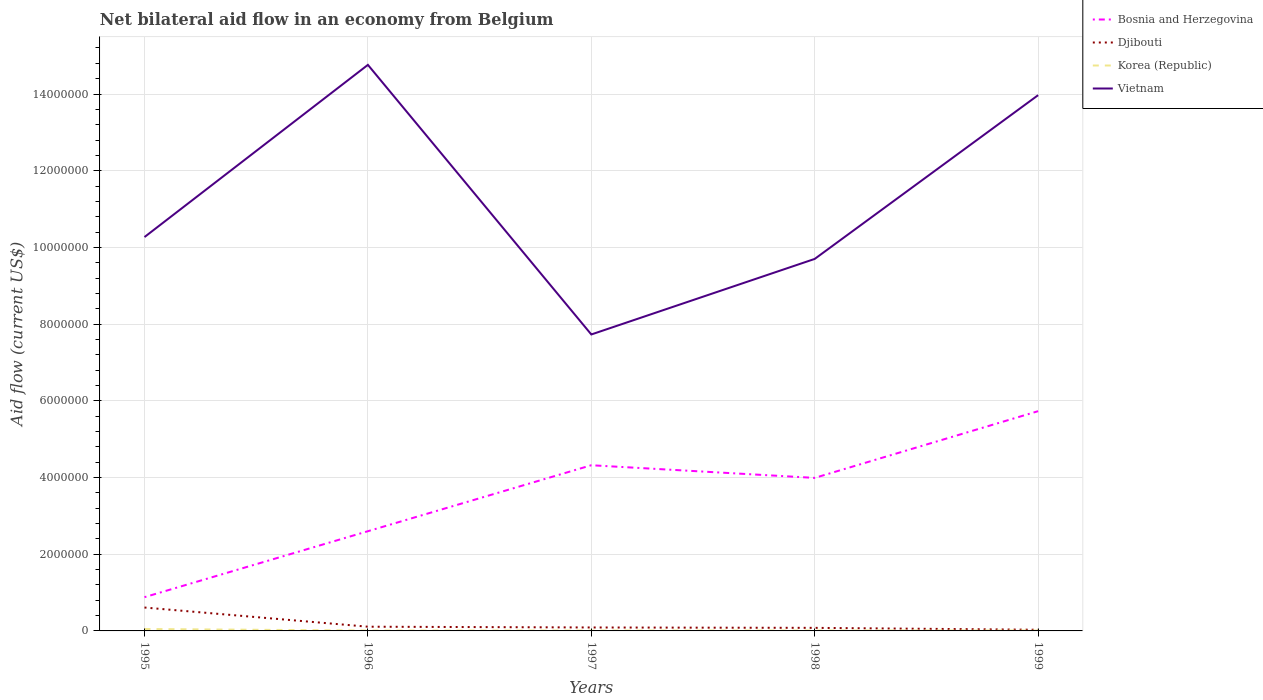How many different coloured lines are there?
Your response must be concise. 4. Across all years, what is the maximum net bilateral aid flow in Vietnam?
Your answer should be very brief. 7.73e+06. What is the total net bilateral aid flow in Korea (Republic) in the graph?
Provide a succinct answer. 0. What is the difference between the highest and the lowest net bilateral aid flow in Korea (Republic)?
Give a very brief answer. 1. What is the difference between two consecutive major ticks on the Y-axis?
Keep it short and to the point. 2.00e+06. Are the values on the major ticks of Y-axis written in scientific E-notation?
Make the answer very short. No. Where does the legend appear in the graph?
Your answer should be very brief. Top right. How many legend labels are there?
Provide a short and direct response. 4. How are the legend labels stacked?
Keep it short and to the point. Vertical. What is the title of the graph?
Offer a very short reply. Net bilateral aid flow in an economy from Belgium. What is the label or title of the X-axis?
Your answer should be very brief. Years. What is the label or title of the Y-axis?
Your answer should be very brief. Aid flow (current US$). What is the Aid flow (current US$) of Bosnia and Herzegovina in 1995?
Give a very brief answer. 8.80e+05. What is the Aid flow (current US$) of Djibouti in 1995?
Provide a succinct answer. 6.10e+05. What is the Aid flow (current US$) in Vietnam in 1995?
Give a very brief answer. 1.03e+07. What is the Aid flow (current US$) of Bosnia and Herzegovina in 1996?
Make the answer very short. 2.60e+06. What is the Aid flow (current US$) in Vietnam in 1996?
Your answer should be very brief. 1.48e+07. What is the Aid flow (current US$) in Bosnia and Herzegovina in 1997?
Keep it short and to the point. 4.32e+06. What is the Aid flow (current US$) of Djibouti in 1997?
Your response must be concise. 9.00e+04. What is the Aid flow (current US$) of Vietnam in 1997?
Your answer should be compact. 7.73e+06. What is the Aid flow (current US$) of Bosnia and Herzegovina in 1998?
Your response must be concise. 3.99e+06. What is the Aid flow (current US$) of Djibouti in 1998?
Provide a short and direct response. 8.00e+04. What is the Aid flow (current US$) of Vietnam in 1998?
Your answer should be compact. 9.70e+06. What is the Aid flow (current US$) in Bosnia and Herzegovina in 1999?
Provide a short and direct response. 5.73e+06. What is the Aid flow (current US$) in Vietnam in 1999?
Ensure brevity in your answer.  1.40e+07. Across all years, what is the maximum Aid flow (current US$) of Bosnia and Herzegovina?
Keep it short and to the point. 5.73e+06. Across all years, what is the maximum Aid flow (current US$) in Djibouti?
Give a very brief answer. 6.10e+05. Across all years, what is the maximum Aid flow (current US$) of Korea (Republic)?
Offer a terse response. 5.00e+04. Across all years, what is the maximum Aid flow (current US$) in Vietnam?
Provide a succinct answer. 1.48e+07. Across all years, what is the minimum Aid flow (current US$) of Bosnia and Herzegovina?
Make the answer very short. 8.80e+05. Across all years, what is the minimum Aid flow (current US$) in Djibouti?
Provide a succinct answer. 3.00e+04. Across all years, what is the minimum Aid flow (current US$) of Vietnam?
Ensure brevity in your answer.  7.73e+06. What is the total Aid flow (current US$) in Bosnia and Herzegovina in the graph?
Offer a very short reply. 1.75e+07. What is the total Aid flow (current US$) of Djibouti in the graph?
Provide a short and direct response. 9.20e+05. What is the total Aid flow (current US$) in Vietnam in the graph?
Ensure brevity in your answer.  5.64e+07. What is the difference between the Aid flow (current US$) in Bosnia and Herzegovina in 1995 and that in 1996?
Make the answer very short. -1.72e+06. What is the difference between the Aid flow (current US$) of Djibouti in 1995 and that in 1996?
Your answer should be very brief. 5.00e+05. What is the difference between the Aid flow (current US$) of Korea (Republic) in 1995 and that in 1996?
Your answer should be compact. 4.00e+04. What is the difference between the Aid flow (current US$) in Vietnam in 1995 and that in 1996?
Ensure brevity in your answer.  -4.49e+06. What is the difference between the Aid flow (current US$) of Bosnia and Herzegovina in 1995 and that in 1997?
Offer a very short reply. -3.44e+06. What is the difference between the Aid flow (current US$) of Djibouti in 1995 and that in 1997?
Make the answer very short. 5.20e+05. What is the difference between the Aid flow (current US$) in Vietnam in 1995 and that in 1997?
Your answer should be compact. 2.54e+06. What is the difference between the Aid flow (current US$) of Bosnia and Herzegovina in 1995 and that in 1998?
Keep it short and to the point. -3.11e+06. What is the difference between the Aid flow (current US$) of Djibouti in 1995 and that in 1998?
Your answer should be compact. 5.30e+05. What is the difference between the Aid flow (current US$) of Vietnam in 1995 and that in 1998?
Make the answer very short. 5.70e+05. What is the difference between the Aid flow (current US$) in Bosnia and Herzegovina in 1995 and that in 1999?
Your answer should be very brief. -4.85e+06. What is the difference between the Aid flow (current US$) of Djibouti in 1995 and that in 1999?
Your response must be concise. 5.80e+05. What is the difference between the Aid flow (current US$) of Korea (Republic) in 1995 and that in 1999?
Your answer should be very brief. 4.00e+04. What is the difference between the Aid flow (current US$) of Vietnam in 1995 and that in 1999?
Ensure brevity in your answer.  -3.70e+06. What is the difference between the Aid flow (current US$) of Bosnia and Herzegovina in 1996 and that in 1997?
Make the answer very short. -1.72e+06. What is the difference between the Aid flow (current US$) of Djibouti in 1996 and that in 1997?
Make the answer very short. 2.00e+04. What is the difference between the Aid flow (current US$) in Korea (Republic) in 1996 and that in 1997?
Give a very brief answer. 0. What is the difference between the Aid flow (current US$) in Vietnam in 1996 and that in 1997?
Your response must be concise. 7.03e+06. What is the difference between the Aid flow (current US$) of Bosnia and Herzegovina in 1996 and that in 1998?
Provide a succinct answer. -1.39e+06. What is the difference between the Aid flow (current US$) in Djibouti in 1996 and that in 1998?
Make the answer very short. 3.00e+04. What is the difference between the Aid flow (current US$) in Vietnam in 1996 and that in 1998?
Give a very brief answer. 5.06e+06. What is the difference between the Aid flow (current US$) of Bosnia and Herzegovina in 1996 and that in 1999?
Make the answer very short. -3.13e+06. What is the difference between the Aid flow (current US$) in Djibouti in 1996 and that in 1999?
Make the answer very short. 8.00e+04. What is the difference between the Aid flow (current US$) of Vietnam in 1996 and that in 1999?
Your answer should be very brief. 7.90e+05. What is the difference between the Aid flow (current US$) in Korea (Republic) in 1997 and that in 1998?
Make the answer very short. 0. What is the difference between the Aid flow (current US$) of Vietnam in 1997 and that in 1998?
Make the answer very short. -1.97e+06. What is the difference between the Aid flow (current US$) of Bosnia and Herzegovina in 1997 and that in 1999?
Your answer should be compact. -1.41e+06. What is the difference between the Aid flow (current US$) in Korea (Republic) in 1997 and that in 1999?
Keep it short and to the point. 0. What is the difference between the Aid flow (current US$) of Vietnam in 1997 and that in 1999?
Keep it short and to the point. -6.24e+06. What is the difference between the Aid flow (current US$) of Bosnia and Herzegovina in 1998 and that in 1999?
Keep it short and to the point. -1.74e+06. What is the difference between the Aid flow (current US$) in Vietnam in 1998 and that in 1999?
Give a very brief answer. -4.27e+06. What is the difference between the Aid flow (current US$) of Bosnia and Herzegovina in 1995 and the Aid flow (current US$) of Djibouti in 1996?
Provide a succinct answer. 7.70e+05. What is the difference between the Aid flow (current US$) in Bosnia and Herzegovina in 1995 and the Aid flow (current US$) in Korea (Republic) in 1996?
Offer a very short reply. 8.70e+05. What is the difference between the Aid flow (current US$) of Bosnia and Herzegovina in 1995 and the Aid flow (current US$) of Vietnam in 1996?
Offer a very short reply. -1.39e+07. What is the difference between the Aid flow (current US$) in Djibouti in 1995 and the Aid flow (current US$) in Korea (Republic) in 1996?
Make the answer very short. 6.00e+05. What is the difference between the Aid flow (current US$) in Djibouti in 1995 and the Aid flow (current US$) in Vietnam in 1996?
Give a very brief answer. -1.42e+07. What is the difference between the Aid flow (current US$) in Korea (Republic) in 1995 and the Aid flow (current US$) in Vietnam in 1996?
Keep it short and to the point. -1.47e+07. What is the difference between the Aid flow (current US$) in Bosnia and Herzegovina in 1995 and the Aid flow (current US$) in Djibouti in 1997?
Provide a succinct answer. 7.90e+05. What is the difference between the Aid flow (current US$) of Bosnia and Herzegovina in 1995 and the Aid flow (current US$) of Korea (Republic) in 1997?
Provide a succinct answer. 8.70e+05. What is the difference between the Aid flow (current US$) of Bosnia and Herzegovina in 1995 and the Aid flow (current US$) of Vietnam in 1997?
Your response must be concise. -6.85e+06. What is the difference between the Aid flow (current US$) in Djibouti in 1995 and the Aid flow (current US$) in Vietnam in 1997?
Give a very brief answer. -7.12e+06. What is the difference between the Aid flow (current US$) of Korea (Republic) in 1995 and the Aid flow (current US$) of Vietnam in 1997?
Your answer should be very brief. -7.68e+06. What is the difference between the Aid flow (current US$) in Bosnia and Herzegovina in 1995 and the Aid flow (current US$) in Korea (Republic) in 1998?
Keep it short and to the point. 8.70e+05. What is the difference between the Aid flow (current US$) in Bosnia and Herzegovina in 1995 and the Aid flow (current US$) in Vietnam in 1998?
Give a very brief answer. -8.82e+06. What is the difference between the Aid flow (current US$) of Djibouti in 1995 and the Aid flow (current US$) of Korea (Republic) in 1998?
Keep it short and to the point. 6.00e+05. What is the difference between the Aid flow (current US$) in Djibouti in 1995 and the Aid flow (current US$) in Vietnam in 1998?
Keep it short and to the point. -9.09e+06. What is the difference between the Aid flow (current US$) in Korea (Republic) in 1995 and the Aid flow (current US$) in Vietnam in 1998?
Give a very brief answer. -9.65e+06. What is the difference between the Aid flow (current US$) in Bosnia and Herzegovina in 1995 and the Aid flow (current US$) in Djibouti in 1999?
Provide a succinct answer. 8.50e+05. What is the difference between the Aid flow (current US$) in Bosnia and Herzegovina in 1995 and the Aid flow (current US$) in Korea (Republic) in 1999?
Provide a succinct answer. 8.70e+05. What is the difference between the Aid flow (current US$) in Bosnia and Herzegovina in 1995 and the Aid flow (current US$) in Vietnam in 1999?
Make the answer very short. -1.31e+07. What is the difference between the Aid flow (current US$) of Djibouti in 1995 and the Aid flow (current US$) of Korea (Republic) in 1999?
Offer a terse response. 6.00e+05. What is the difference between the Aid flow (current US$) in Djibouti in 1995 and the Aid flow (current US$) in Vietnam in 1999?
Your answer should be very brief. -1.34e+07. What is the difference between the Aid flow (current US$) in Korea (Republic) in 1995 and the Aid flow (current US$) in Vietnam in 1999?
Make the answer very short. -1.39e+07. What is the difference between the Aid flow (current US$) in Bosnia and Herzegovina in 1996 and the Aid flow (current US$) in Djibouti in 1997?
Offer a very short reply. 2.51e+06. What is the difference between the Aid flow (current US$) of Bosnia and Herzegovina in 1996 and the Aid flow (current US$) of Korea (Republic) in 1997?
Provide a succinct answer. 2.59e+06. What is the difference between the Aid flow (current US$) of Bosnia and Herzegovina in 1996 and the Aid flow (current US$) of Vietnam in 1997?
Ensure brevity in your answer.  -5.13e+06. What is the difference between the Aid flow (current US$) in Djibouti in 1996 and the Aid flow (current US$) in Korea (Republic) in 1997?
Offer a very short reply. 1.00e+05. What is the difference between the Aid flow (current US$) in Djibouti in 1996 and the Aid flow (current US$) in Vietnam in 1997?
Your answer should be very brief. -7.62e+06. What is the difference between the Aid flow (current US$) in Korea (Republic) in 1996 and the Aid flow (current US$) in Vietnam in 1997?
Keep it short and to the point. -7.72e+06. What is the difference between the Aid flow (current US$) of Bosnia and Herzegovina in 1996 and the Aid flow (current US$) of Djibouti in 1998?
Your answer should be very brief. 2.52e+06. What is the difference between the Aid flow (current US$) of Bosnia and Herzegovina in 1996 and the Aid flow (current US$) of Korea (Republic) in 1998?
Provide a succinct answer. 2.59e+06. What is the difference between the Aid flow (current US$) in Bosnia and Herzegovina in 1996 and the Aid flow (current US$) in Vietnam in 1998?
Ensure brevity in your answer.  -7.10e+06. What is the difference between the Aid flow (current US$) of Djibouti in 1996 and the Aid flow (current US$) of Korea (Republic) in 1998?
Offer a very short reply. 1.00e+05. What is the difference between the Aid flow (current US$) of Djibouti in 1996 and the Aid flow (current US$) of Vietnam in 1998?
Offer a very short reply. -9.59e+06. What is the difference between the Aid flow (current US$) in Korea (Republic) in 1996 and the Aid flow (current US$) in Vietnam in 1998?
Your answer should be very brief. -9.69e+06. What is the difference between the Aid flow (current US$) in Bosnia and Herzegovina in 1996 and the Aid flow (current US$) in Djibouti in 1999?
Make the answer very short. 2.57e+06. What is the difference between the Aid flow (current US$) in Bosnia and Herzegovina in 1996 and the Aid flow (current US$) in Korea (Republic) in 1999?
Make the answer very short. 2.59e+06. What is the difference between the Aid flow (current US$) of Bosnia and Herzegovina in 1996 and the Aid flow (current US$) of Vietnam in 1999?
Offer a very short reply. -1.14e+07. What is the difference between the Aid flow (current US$) of Djibouti in 1996 and the Aid flow (current US$) of Vietnam in 1999?
Give a very brief answer. -1.39e+07. What is the difference between the Aid flow (current US$) in Korea (Republic) in 1996 and the Aid flow (current US$) in Vietnam in 1999?
Your answer should be compact. -1.40e+07. What is the difference between the Aid flow (current US$) in Bosnia and Herzegovina in 1997 and the Aid flow (current US$) in Djibouti in 1998?
Your answer should be very brief. 4.24e+06. What is the difference between the Aid flow (current US$) in Bosnia and Herzegovina in 1997 and the Aid flow (current US$) in Korea (Republic) in 1998?
Your answer should be very brief. 4.31e+06. What is the difference between the Aid flow (current US$) of Bosnia and Herzegovina in 1997 and the Aid flow (current US$) of Vietnam in 1998?
Make the answer very short. -5.38e+06. What is the difference between the Aid flow (current US$) of Djibouti in 1997 and the Aid flow (current US$) of Korea (Republic) in 1998?
Your response must be concise. 8.00e+04. What is the difference between the Aid flow (current US$) in Djibouti in 1997 and the Aid flow (current US$) in Vietnam in 1998?
Keep it short and to the point. -9.61e+06. What is the difference between the Aid flow (current US$) in Korea (Republic) in 1997 and the Aid flow (current US$) in Vietnam in 1998?
Your answer should be very brief. -9.69e+06. What is the difference between the Aid flow (current US$) of Bosnia and Herzegovina in 1997 and the Aid flow (current US$) of Djibouti in 1999?
Keep it short and to the point. 4.29e+06. What is the difference between the Aid flow (current US$) in Bosnia and Herzegovina in 1997 and the Aid flow (current US$) in Korea (Republic) in 1999?
Ensure brevity in your answer.  4.31e+06. What is the difference between the Aid flow (current US$) in Bosnia and Herzegovina in 1997 and the Aid flow (current US$) in Vietnam in 1999?
Your answer should be very brief. -9.65e+06. What is the difference between the Aid flow (current US$) of Djibouti in 1997 and the Aid flow (current US$) of Vietnam in 1999?
Ensure brevity in your answer.  -1.39e+07. What is the difference between the Aid flow (current US$) of Korea (Republic) in 1997 and the Aid flow (current US$) of Vietnam in 1999?
Provide a succinct answer. -1.40e+07. What is the difference between the Aid flow (current US$) in Bosnia and Herzegovina in 1998 and the Aid flow (current US$) in Djibouti in 1999?
Provide a short and direct response. 3.96e+06. What is the difference between the Aid flow (current US$) in Bosnia and Herzegovina in 1998 and the Aid flow (current US$) in Korea (Republic) in 1999?
Offer a terse response. 3.98e+06. What is the difference between the Aid flow (current US$) of Bosnia and Herzegovina in 1998 and the Aid flow (current US$) of Vietnam in 1999?
Give a very brief answer. -9.98e+06. What is the difference between the Aid flow (current US$) in Djibouti in 1998 and the Aid flow (current US$) in Vietnam in 1999?
Your answer should be very brief. -1.39e+07. What is the difference between the Aid flow (current US$) of Korea (Republic) in 1998 and the Aid flow (current US$) of Vietnam in 1999?
Your answer should be compact. -1.40e+07. What is the average Aid flow (current US$) of Bosnia and Herzegovina per year?
Offer a terse response. 3.50e+06. What is the average Aid flow (current US$) of Djibouti per year?
Ensure brevity in your answer.  1.84e+05. What is the average Aid flow (current US$) in Korea (Republic) per year?
Offer a very short reply. 1.80e+04. What is the average Aid flow (current US$) of Vietnam per year?
Ensure brevity in your answer.  1.13e+07. In the year 1995, what is the difference between the Aid flow (current US$) in Bosnia and Herzegovina and Aid flow (current US$) in Korea (Republic)?
Ensure brevity in your answer.  8.30e+05. In the year 1995, what is the difference between the Aid flow (current US$) in Bosnia and Herzegovina and Aid flow (current US$) in Vietnam?
Ensure brevity in your answer.  -9.39e+06. In the year 1995, what is the difference between the Aid flow (current US$) of Djibouti and Aid flow (current US$) of Korea (Republic)?
Make the answer very short. 5.60e+05. In the year 1995, what is the difference between the Aid flow (current US$) of Djibouti and Aid flow (current US$) of Vietnam?
Provide a short and direct response. -9.66e+06. In the year 1995, what is the difference between the Aid flow (current US$) in Korea (Republic) and Aid flow (current US$) in Vietnam?
Your answer should be compact. -1.02e+07. In the year 1996, what is the difference between the Aid flow (current US$) of Bosnia and Herzegovina and Aid flow (current US$) of Djibouti?
Your answer should be very brief. 2.49e+06. In the year 1996, what is the difference between the Aid flow (current US$) in Bosnia and Herzegovina and Aid flow (current US$) in Korea (Republic)?
Ensure brevity in your answer.  2.59e+06. In the year 1996, what is the difference between the Aid flow (current US$) of Bosnia and Herzegovina and Aid flow (current US$) of Vietnam?
Your response must be concise. -1.22e+07. In the year 1996, what is the difference between the Aid flow (current US$) in Djibouti and Aid flow (current US$) in Korea (Republic)?
Your response must be concise. 1.00e+05. In the year 1996, what is the difference between the Aid flow (current US$) in Djibouti and Aid flow (current US$) in Vietnam?
Provide a succinct answer. -1.46e+07. In the year 1996, what is the difference between the Aid flow (current US$) of Korea (Republic) and Aid flow (current US$) of Vietnam?
Your answer should be very brief. -1.48e+07. In the year 1997, what is the difference between the Aid flow (current US$) of Bosnia and Herzegovina and Aid flow (current US$) of Djibouti?
Ensure brevity in your answer.  4.23e+06. In the year 1997, what is the difference between the Aid flow (current US$) of Bosnia and Herzegovina and Aid flow (current US$) of Korea (Republic)?
Offer a terse response. 4.31e+06. In the year 1997, what is the difference between the Aid flow (current US$) in Bosnia and Herzegovina and Aid flow (current US$) in Vietnam?
Your response must be concise. -3.41e+06. In the year 1997, what is the difference between the Aid flow (current US$) in Djibouti and Aid flow (current US$) in Korea (Republic)?
Your answer should be compact. 8.00e+04. In the year 1997, what is the difference between the Aid flow (current US$) of Djibouti and Aid flow (current US$) of Vietnam?
Make the answer very short. -7.64e+06. In the year 1997, what is the difference between the Aid flow (current US$) in Korea (Republic) and Aid flow (current US$) in Vietnam?
Ensure brevity in your answer.  -7.72e+06. In the year 1998, what is the difference between the Aid flow (current US$) of Bosnia and Herzegovina and Aid flow (current US$) of Djibouti?
Ensure brevity in your answer.  3.91e+06. In the year 1998, what is the difference between the Aid flow (current US$) of Bosnia and Herzegovina and Aid flow (current US$) of Korea (Republic)?
Your answer should be compact. 3.98e+06. In the year 1998, what is the difference between the Aid flow (current US$) of Bosnia and Herzegovina and Aid flow (current US$) of Vietnam?
Your response must be concise. -5.71e+06. In the year 1998, what is the difference between the Aid flow (current US$) in Djibouti and Aid flow (current US$) in Vietnam?
Make the answer very short. -9.62e+06. In the year 1998, what is the difference between the Aid flow (current US$) in Korea (Republic) and Aid flow (current US$) in Vietnam?
Provide a short and direct response. -9.69e+06. In the year 1999, what is the difference between the Aid flow (current US$) in Bosnia and Herzegovina and Aid flow (current US$) in Djibouti?
Provide a succinct answer. 5.70e+06. In the year 1999, what is the difference between the Aid flow (current US$) of Bosnia and Herzegovina and Aid flow (current US$) of Korea (Republic)?
Give a very brief answer. 5.72e+06. In the year 1999, what is the difference between the Aid flow (current US$) of Bosnia and Herzegovina and Aid flow (current US$) of Vietnam?
Keep it short and to the point. -8.24e+06. In the year 1999, what is the difference between the Aid flow (current US$) in Djibouti and Aid flow (current US$) in Vietnam?
Provide a succinct answer. -1.39e+07. In the year 1999, what is the difference between the Aid flow (current US$) of Korea (Republic) and Aid flow (current US$) of Vietnam?
Offer a terse response. -1.40e+07. What is the ratio of the Aid flow (current US$) in Bosnia and Herzegovina in 1995 to that in 1996?
Ensure brevity in your answer.  0.34. What is the ratio of the Aid flow (current US$) of Djibouti in 1995 to that in 1996?
Offer a very short reply. 5.55. What is the ratio of the Aid flow (current US$) of Vietnam in 1995 to that in 1996?
Your answer should be very brief. 0.7. What is the ratio of the Aid flow (current US$) of Bosnia and Herzegovina in 1995 to that in 1997?
Make the answer very short. 0.2. What is the ratio of the Aid flow (current US$) of Djibouti in 1995 to that in 1997?
Provide a succinct answer. 6.78. What is the ratio of the Aid flow (current US$) in Korea (Republic) in 1995 to that in 1997?
Keep it short and to the point. 5. What is the ratio of the Aid flow (current US$) of Vietnam in 1995 to that in 1997?
Your answer should be very brief. 1.33. What is the ratio of the Aid flow (current US$) of Bosnia and Herzegovina in 1995 to that in 1998?
Ensure brevity in your answer.  0.22. What is the ratio of the Aid flow (current US$) in Djibouti in 1995 to that in 1998?
Ensure brevity in your answer.  7.62. What is the ratio of the Aid flow (current US$) in Vietnam in 1995 to that in 1998?
Ensure brevity in your answer.  1.06. What is the ratio of the Aid flow (current US$) in Bosnia and Herzegovina in 1995 to that in 1999?
Ensure brevity in your answer.  0.15. What is the ratio of the Aid flow (current US$) in Djibouti in 1995 to that in 1999?
Provide a succinct answer. 20.33. What is the ratio of the Aid flow (current US$) in Korea (Republic) in 1995 to that in 1999?
Provide a succinct answer. 5. What is the ratio of the Aid flow (current US$) of Vietnam in 1995 to that in 1999?
Ensure brevity in your answer.  0.74. What is the ratio of the Aid flow (current US$) of Bosnia and Herzegovina in 1996 to that in 1997?
Your response must be concise. 0.6. What is the ratio of the Aid flow (current US$) in Djibouti in 1996 to that in 1997?
Keep it short and to the point. 1.22. What is the ratio of the Aid flow (current US$) in Vietnam in 1996 to that in 1997?
Ensure brevity in your answer.  1.91. What is the ratio of the Aid flow (current US$) in Bosnia and Herzegovina in 1996 to that in 1998?
Provide a short and direct response. 0.65. What is the ratio of the Aid flow (current US$) in Djibouti in 1996 to that in 1998?
Provide a succinct answer. 1.38. What is the ratio of the Aid flow (current US$) in Korea (Republic) in 1996 to that in 1998?
Give a very brief answer. 1. What is the ratio of the Aid flow (current US$) of Vietnam in 1996 to that in 1998?
Provide a succinct answer. 1.52. What is the ratio of the Aid flow (current US$) of Bosnia and Herzegovina in 1996 to that in 1999?
Your answer should be very brief. 0.45. What is the ratio of the Aid flow (current US$) of Djibouti in 1996 to that in 1999?
Keep it short and to the point. 3.67. What is the ratio of the Aid flow (current US$) of Vietnam in 1996 to that in 1999?
Keep it short and to the point. 1.06. What is the ratio of the Aid flow (current US$) of Bosnia and Herzegovina in 1997 to that in 1998?
Give a very brief answer. 1.08. What is the ratio of the Aid flow (current US$) of Korea (Republic) in 1997 to that in 1998?
Keep it short and to the point. 1. What is the ratio of the Aid flow (current US$) of Vietnam in 1997 to that in 1998?
Your answer should be very brief. 0.8. What is the ratio of the Aid flow (current US$) in Bosnia and Herzegovina in 1997 to that in 1999?
Your response must be concise. 0.75. What is the ratio of the Aid flow (current US$) in Korea (Republic) in 1997 to that in 1999?
Provide a short and direct response. 1. What is the ratio of the Aid flow (current US$) in Vietnam in 1997 to that in 1999?
Your answer should be very brief. 0.55. What is the ratio of the Aid flow (current US$) of Bosnia and Herzegovina in 1998 to that in 1999?
Your response must be concise. 0.7. What is the ratio of the Aid flow (current US$) of Djibouti in 1998 to that in 1999?
Keep it short and to the point. 2.67. What is the ratio of the Aid flow (current US$) of Korea (Republic) in 1998 to that in 1999?
Make the answer very short. 1. What is the ratio of the Aid flow (current US$) of Vietnam in 1998 to that in 1999?
Make the answer very short. 0.69. What is the difference between the highest and the second highest Aid flow (current US$) in Bosnia and Herzegovina?
Provide a short and direct response. 1.41e+06. What is the difference between the highest and the second highest Aid flow (current US$) in Vietnam?
Ensure brevity in your answer.  7.90e+05. What is the difference between the highest and the lowest Aid flow (current US$) of Bosnia and Herzegovina?
Your answer should be very brief. 4.85e+06. What is the difference between the highest and the lowest Aid flow (current US$) of Djibouti?
Provide a short and direct response. 5.80e+05. What is the difference between the highest and the lowest Aid flow (current US$) of Vietnam?
Make the answer very short. 7.03e+06. 